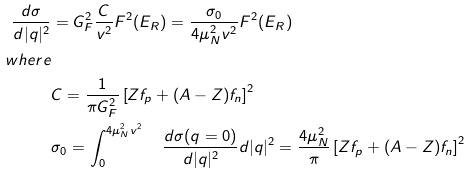Convert formula to latex. <formula><loc_0><loc_0><loc_500><loc_500>\frac { d \sigma } { d | q | ^ { 2 } } & = G _ { F } ^ { 2 } \frac { C } { v ^ { 2 } } F ^ { 2 } ( E _ { R } ) = \frac { \sigma _ { 0 } } { 4 \mu _ { N } ^ { 2 } v ^ { 2 } } F ^ { 2 } ( E _ { R } ) \\ w h e r e & \\ & C = \frac { 1 } { \pi G _ { F } ^ { 2 } } \left [ Z f _ { p } + ( A - Z ) f _ { n } \right ] ^ { 2 } \\ & \sigma _ { 0 } = \int _ { 0 } ^ { 4 \mu _ { N } ^ { 2 } v ^ { 2 } } \quad \frac { d \sigma ( q = 0 ) } { d | q | ^ { 2 } } d | q | ^ { 2 } = \frac { 4 \mu _ { N } ^ { 2 } } { \pi } \left [ Z f _ { p } + ( A - Z ) f _ { n } \right ] ^ { 2 }</formula> 